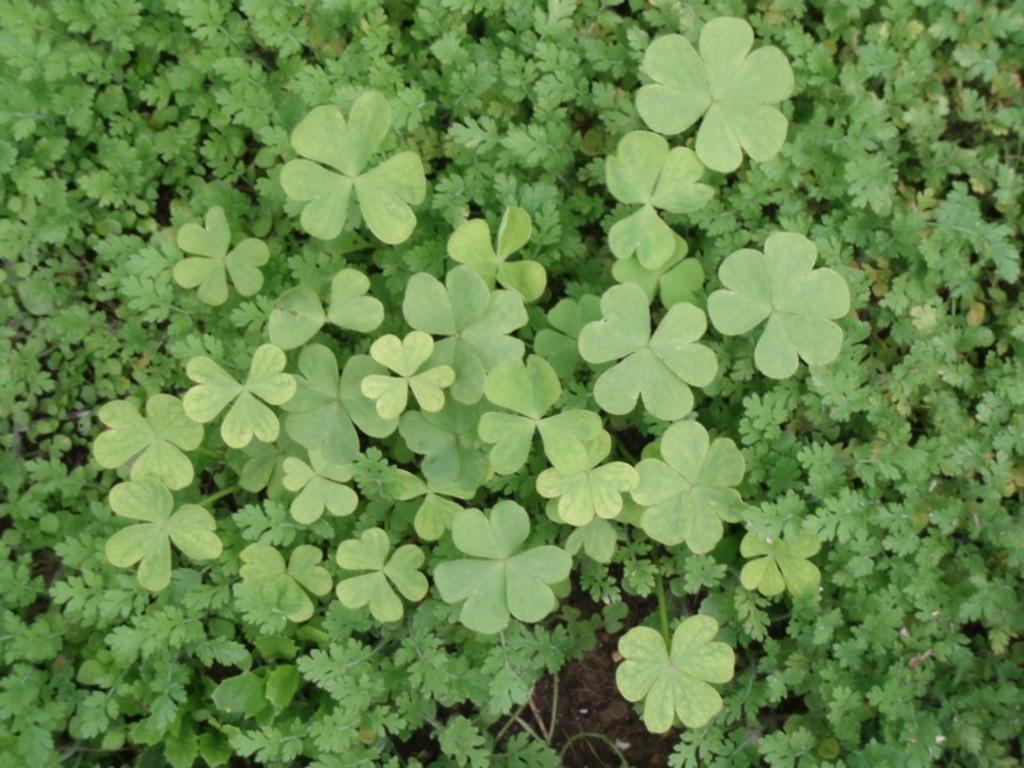What type of clothing is visible in the image? There are pants in the image. What color are the plants in the image? The plants in the image are green. Is there a beggar sitting next to the pants in the image? There is no beggar present in the image. How many legs can be seen on the pants in the image? The image does not show the pants being worn by a person, so it is not possible to determine the number of legs. 